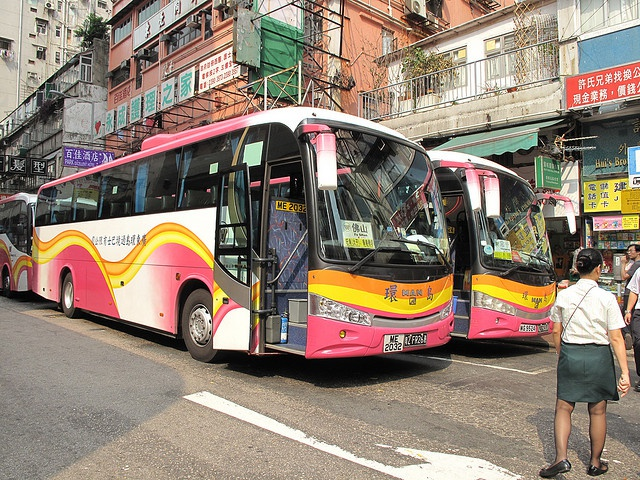Describe the objects in this image and their specific colors. I can see bus in lightgray, black, gray, white, and salmon tones, bus in lightgray, black, gray, white, and salmon tones, people in lightgray, white, gray, and black tones, bus in lightgray, black, gray, darkgray, and maroon tones, and people in lightgray, black, gray, and tan tones in this image. 